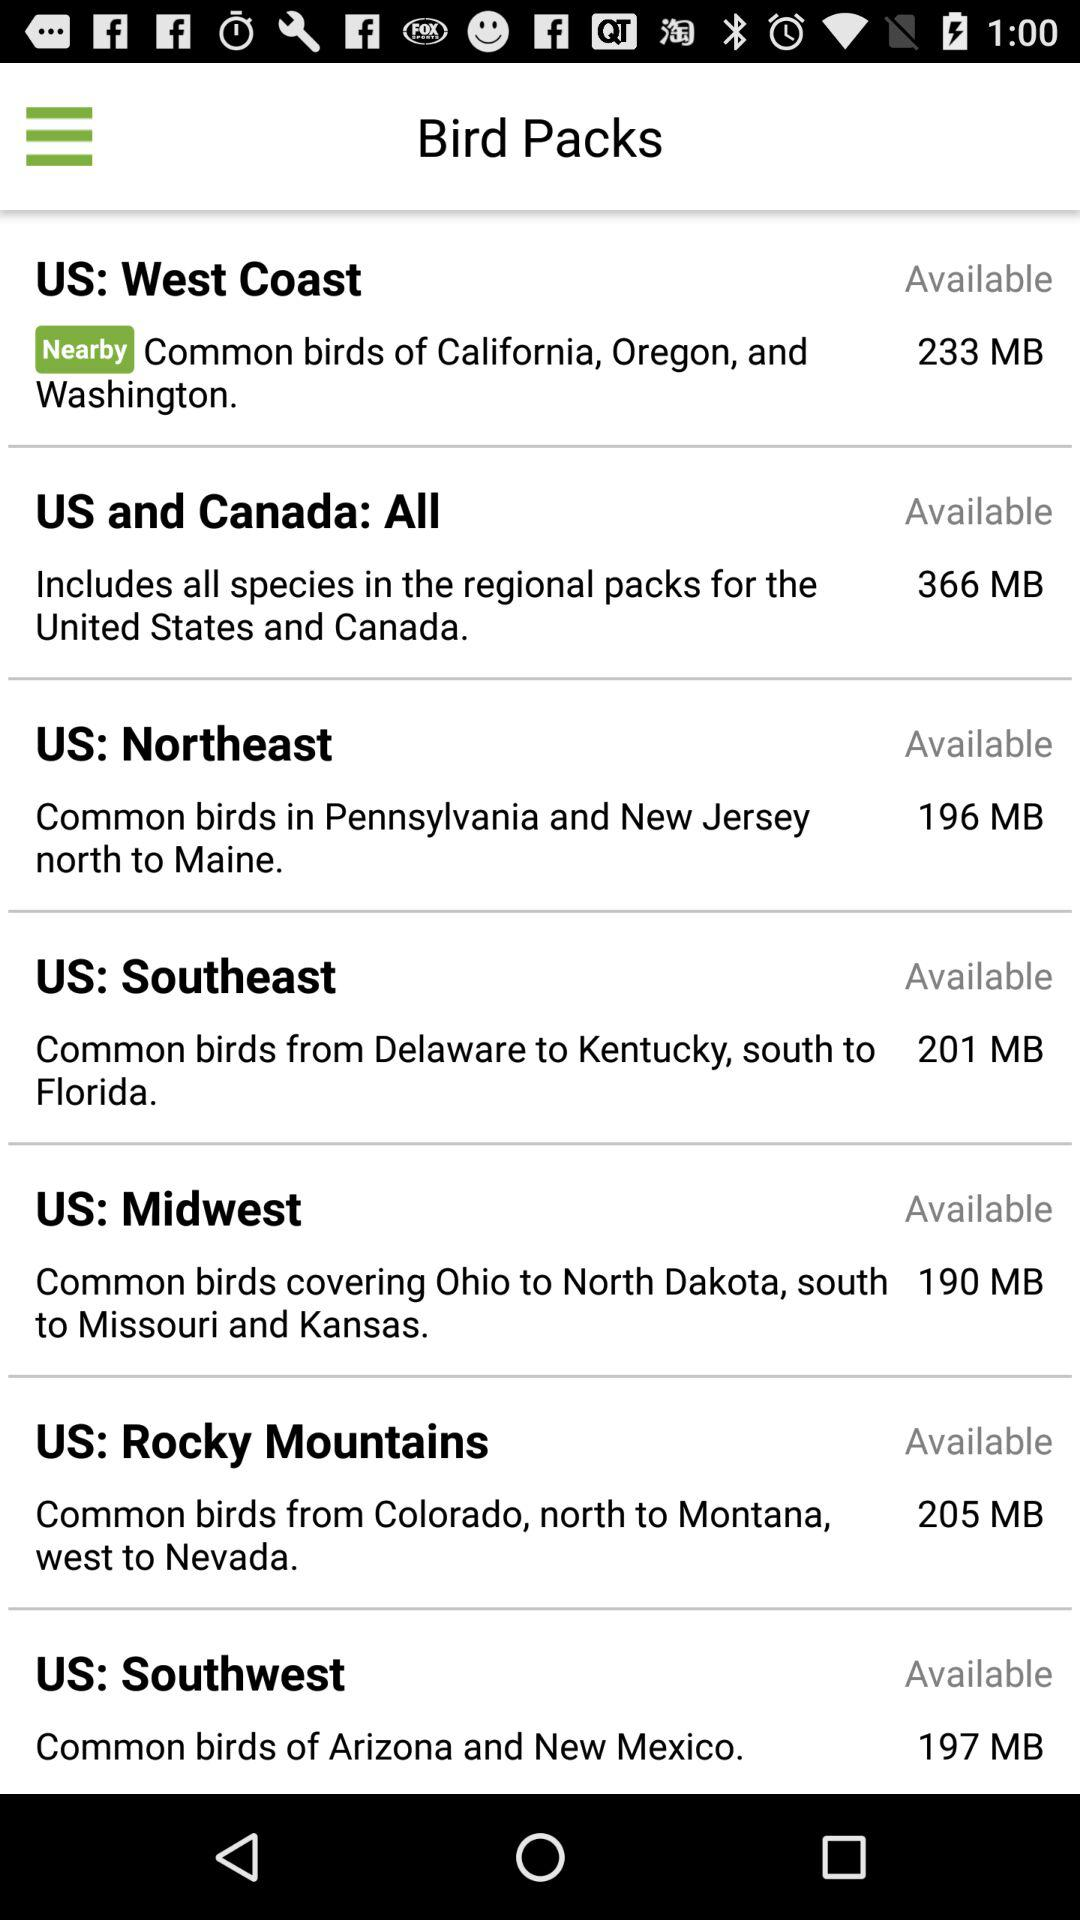Which bird pack is available with a size of 201 MB? The bird pack is "US: Southeast". 